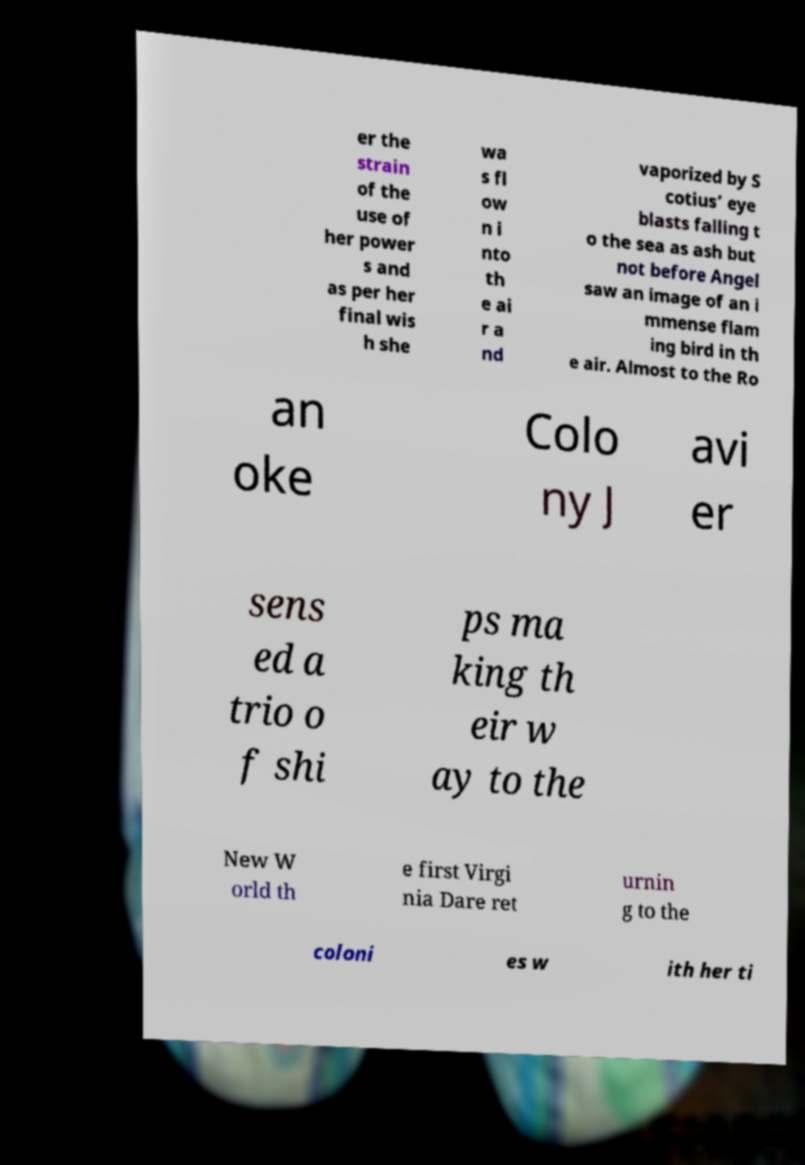For documentation purposes, I need the text within this image transcribed. Could you provide that? er the strain of the use of her power s and as per her final wis h she wa s fl ow n i nto th e ai r a nd vaporized by S cotius’ eye blasts falling t o the sea as ash but not before Angel saw an image of an i mmense flam ing bird in th e air. Almost to the Ro an oke Colo ny J avi er sens ed a trio o f shi ps ma king th eir w ay to the New W orld th e first Virgi nia Dare ret urnin g to the coloni es w ith her ti 